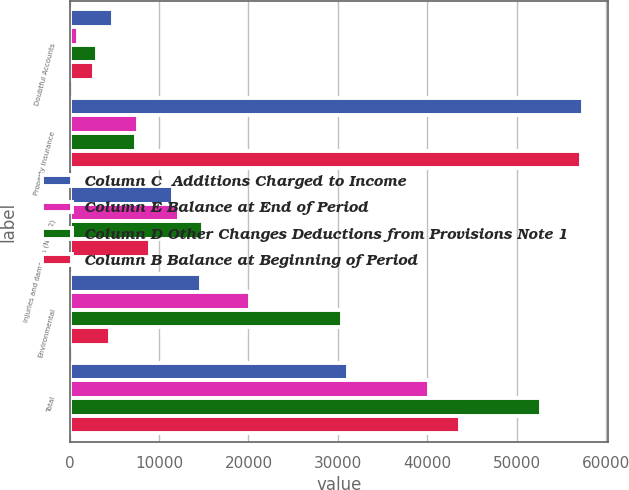Convert chart. <chart><loc_0><loc_0><loc_500><loc_500><stacked_bar_chart><ecel><fcel>Doubtful Accounts<fcel>Property insurance<fcel>Injuries and damages (Note 2)<fcel>Environmental<fcel>Total<nl><fcel>Column C  Additions Charged to Income<fcel>4856<fcel>57353<fcel>11554<fcel>14711<fcel>31088<nl><fcel>Column E Balance at End of Period<fcel>889<fcel>7673<fcel>12288<fcel>20201<fcel>40162<nl><fcel>Column D Other Changes Deductions from Provisions Note 1<fcel>3058<fcel>7453<fcel>14872<fcel>30430<fcel>52755<nl><fcel>Column B Balance at Beginning of Period<fcel>2687<fcel>57133<fcel>8970<fcel>4482<fcel>43681<nl></chart> 